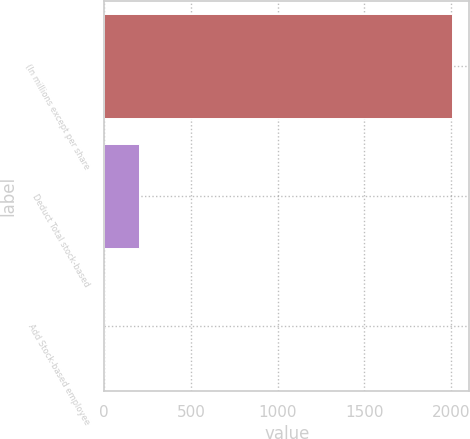Convert chart. <chart><loc_0><loc_0><loc_500><loc_500><bar_chart><fcel>(In millions except per share<fcel>Deduct Total stock-based<fcel>Add Stock-based employee<nl><fcel>2006<fcel>202.4<fcel>2<nl></chart> 